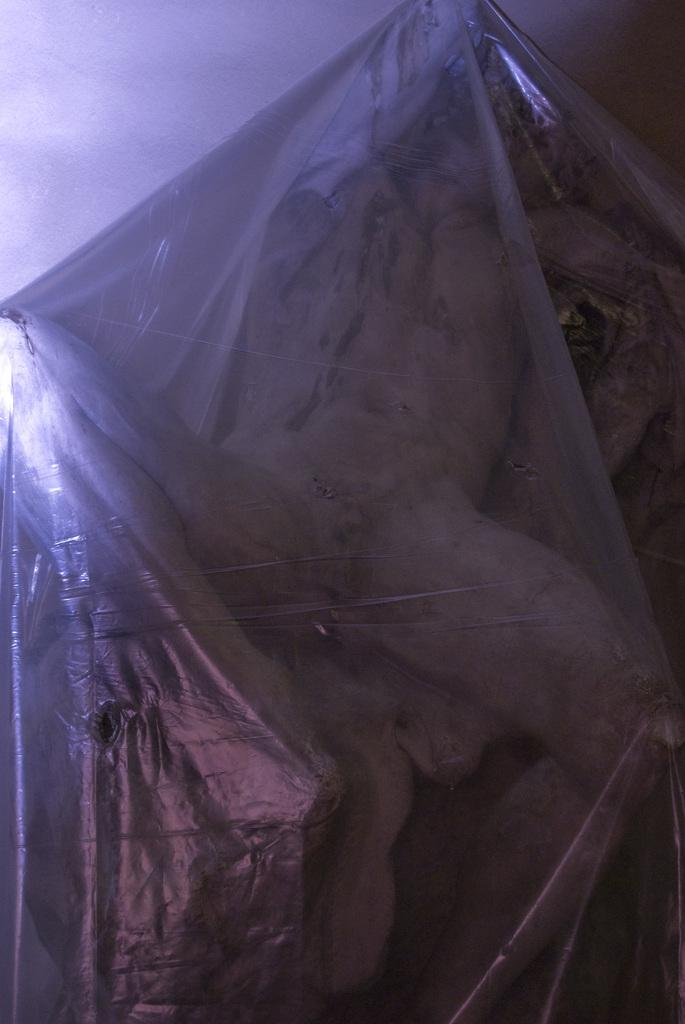What is the main subject in the image? There is a statue in the image. What is the condition of the statue? The statue is covered with a sheet. What else can be seen in the image? There is a wall visible in the image. What type of behavior is the crow exhibiting in the image? There is no crow present in the image, so it is not possible to determine its behavior. What is the theme of the birthday party in the image? There is no birthday party depicted in the image. 